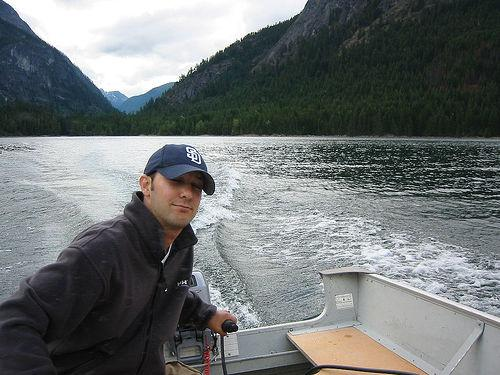Deduce the reasoning behind the man's choice of attire for this setting. The man's choice of attire, including the blue cap, blue jacket, and grey sweater, suggests that he is dressed for a cool or chilly day outdoors, ensuring comfort and protection while boating. How would you gauge the quality of the photo? The photo is of high quality, with clear visibility of the various elements and details present, like the man's clothing, the boat structure, and the surrounding landscape. Is the photo clear, and can you describe the context in which it was taken? Yes, the photo is clear. It was taken outside during the day, displaying a man enjoying a boat ride on a calm lake with mountains and trees in the background. Count the number of objects related to the boat and the man in the image. 10 objects - man, blue cap, white logo on cap, blue jacket, grey sweater, black handle, white boat, wooden bench, small spot on bench, and tan boat engine. Identify the key elements of the environment surrounding the main subject in the image. The man in the boat is surrounded by mountains, green trees, a body of dark green water with white waves, and a clear sky with white clouds. Provide a brief summary of the scene depicted in the image. A man wearing a blue cap and jacket is driving a boat with a wooden bench, while smiling and gripping a handle, with mountains, green trees, and choppy waters in the background. What is the man wearing, and what does he have in his hand? The man is wearing a dark blue cap with a white logo, a blue jacket, and a grey sweater. He has a black handle in his hand. What is the most significant sentiment depicted in this image? The sentiment conveyed in the image is of happiness and enjoyment, as the man is seen smiling while driving the boat amidst beautiful natural surroundings. Determine whether there is any interaction between the man and his environment, and describe the interaction. Yes, the man is interacting with his environment by gripping a handle to control the boat and creating ripples and waves in the water while driving on the lake. Describe the position and state of the trees seen in the image. The green trees are placed along the mountain in the background, filling a large portion of the image with a lively landscape. 